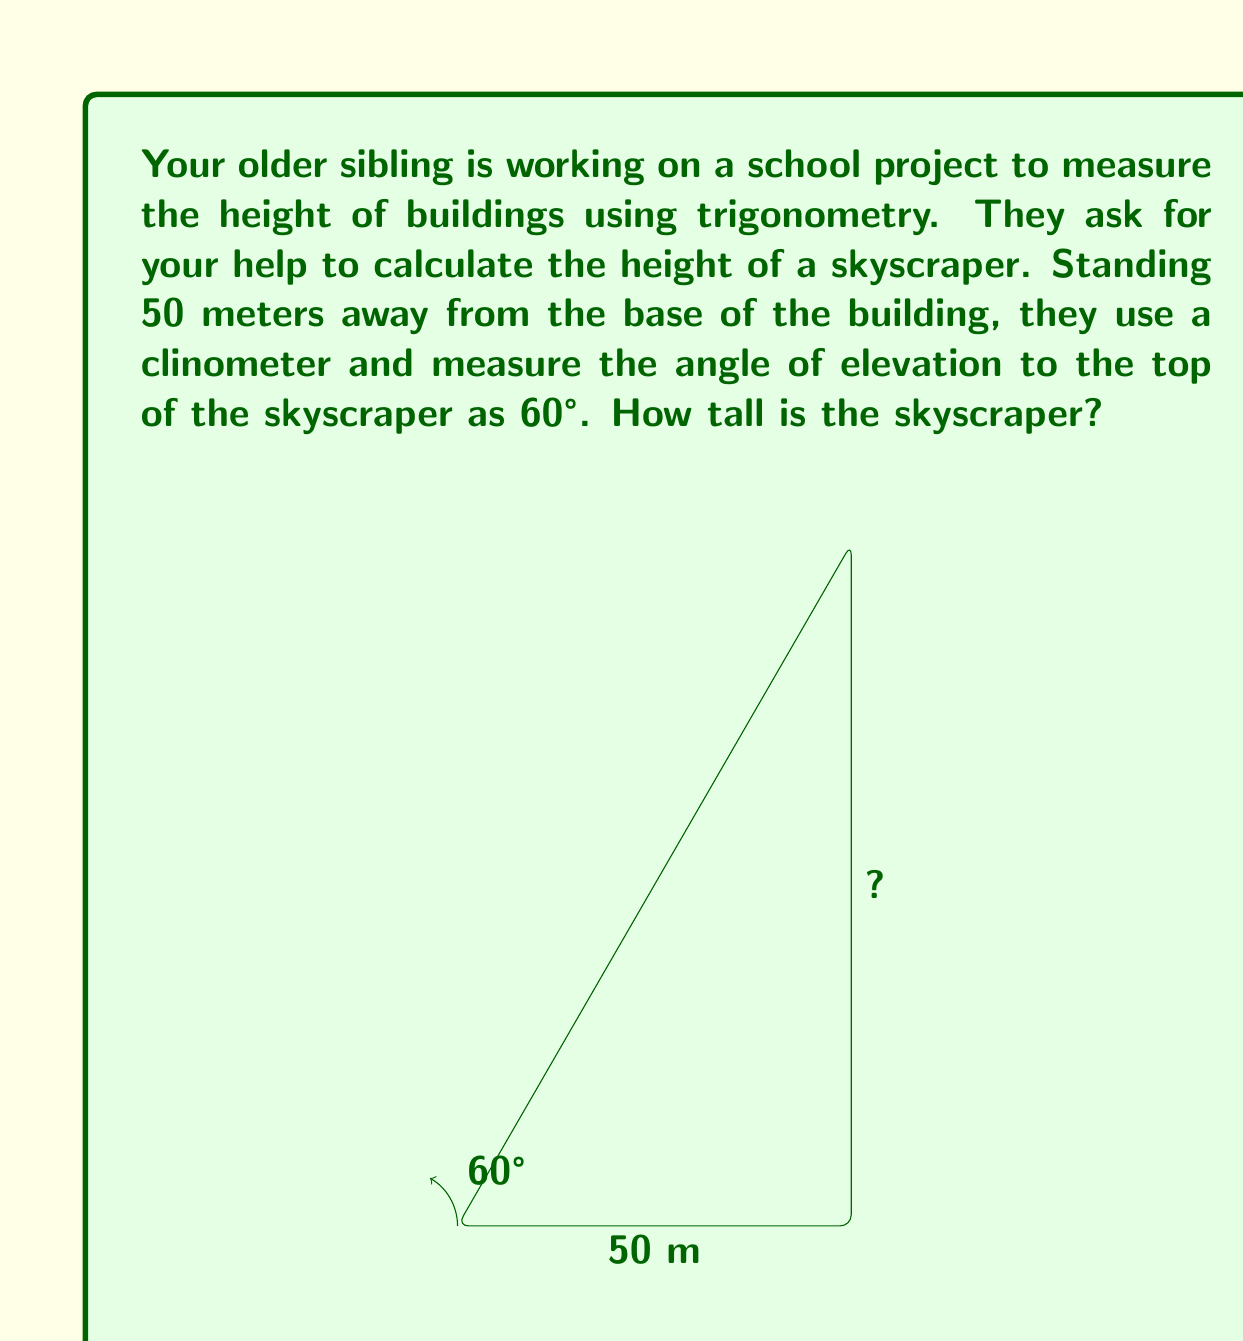Can you answer this question? Let's approach this step-by-step:

1) In this problem, we have a right triangle. The known parts are:
   - The adjacent side (distance from the observer to the building): 50 meters
   - The angle of elevation: 60°

2) We need to find the opposite side (height of the building). This is a perfect scenario to use the tangent function.

3) Recall that tangent is the ratio of the opposite side to the adjacent side:

   $$\tan \theta = \frac{\text{opposite}}{\text{adjacent}}$$

4) Let's call the height of the building $h$. We can set up the equation:

   $$\tan 60° = \frac{h}{50}$$

5) To solve for $h$, we multiply both sides by 50:

   $$h = 50 \tan 60°$$

6) Now, we need to calculate $\tan 60°$. This is a standard angle, and its tangent is $\sqrt{3}$.

7) Substituting this value:

   $$h = 50 \sqrt{3}$$

8) To get a decimal approximation, we can use a calculator:

   $$h \approx 50 * 1.7321 \approx 86.60 \text{ meters}$$

Thus, the skyscraper is approximately 86.60 meters tall.
Answer: $h = 50\sqrt{3} \approx 86.60 \text{ meters}$ 